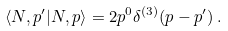Convert formula to latex. <formula><loc_0><loc_0><loc_500><loc_500>\langle N , p ^ { \prime } | N , p \rangle = 2 p ^ { 0 } \delta ^ { ( 3 ) } ( { p } - { p } ^ { \prime } ) \, .</formula> 